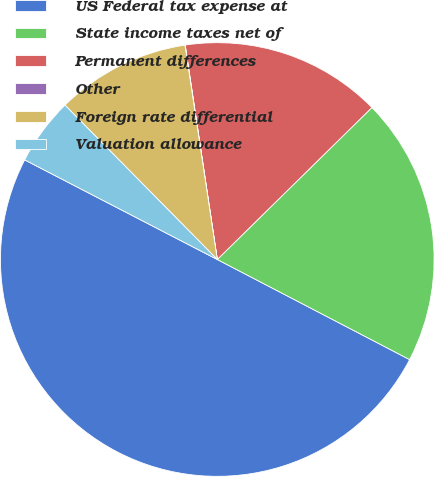Convert chart to OTSL. <chart><loc_0><loc_0><loc_500><loc_500><pie_chart><fcel>US Federal tax expense at<fcel>State income taxes net of<fcel>Permanent differences<fcel>Other<fcel>Foreign rate differential<fcel>Valuation allowance<nl><fcel>49.96%<fcel>20.0%<fcel>15.0%<fcel>0.02%<fcel>10.01%<fcel>5.01%<nl></chart> 